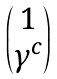Convert formula to latex. <formula><loc_0><loc_0><loc_500><loc_500>\begin{pmatrix} 1 \\ \gamma ^ { c } \end{pmatrix}</formula> 